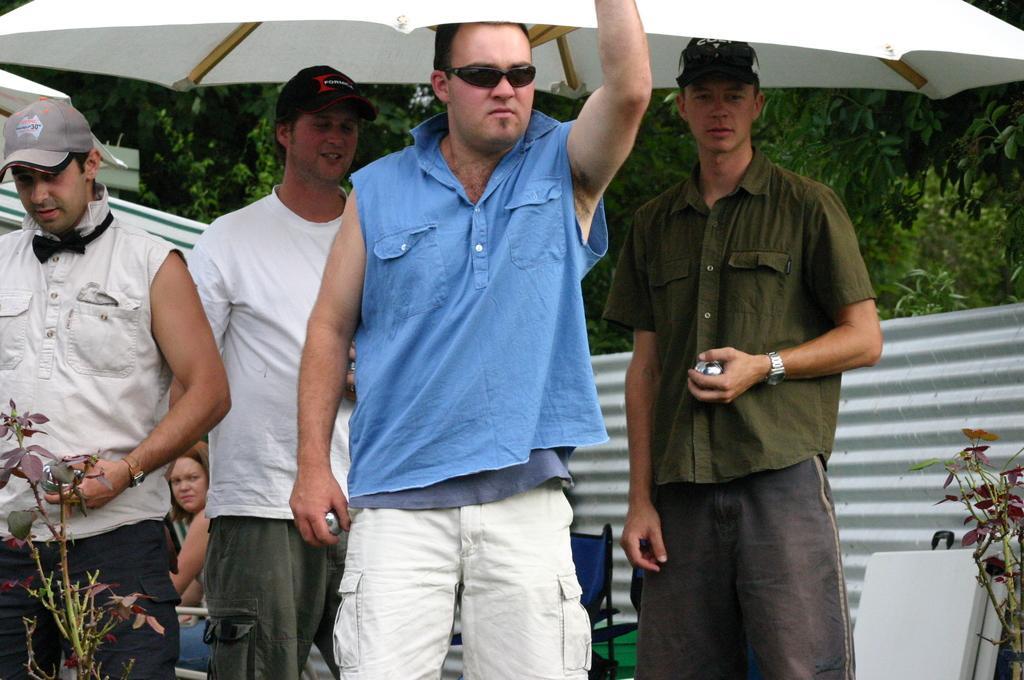Describe this image in one or two sentences. In this picture I can observe for men. One of them is wearing spectacles. I can observe and white color umbrella on the top of the picture. In background there are trees. 